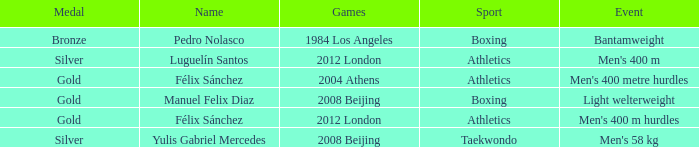Which Sport had an Event of men's 400 m hurdles? Athletics. 